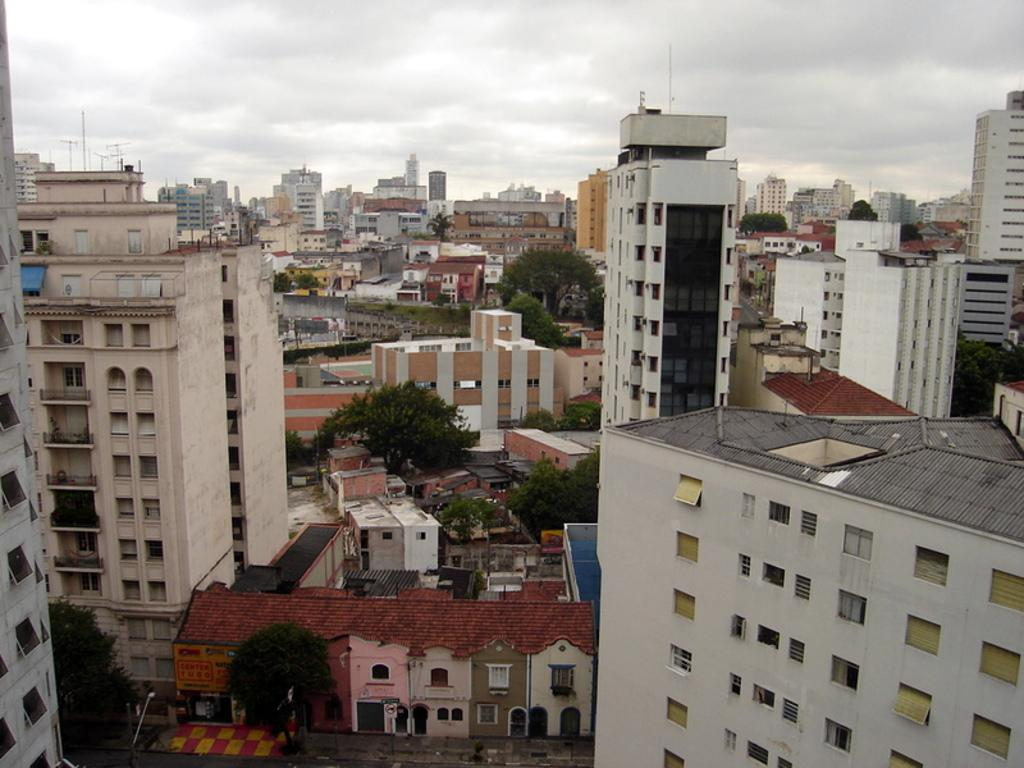What type of structures can be seen in the image? There are buildings in the image. What type of vegetation is present in the image? There are trees in the image. What color is the collar on the finger in the image? There is no finger or collar present in the image. 